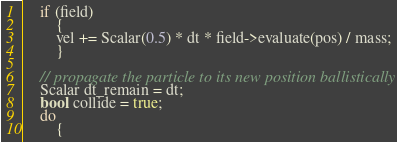Convert code to text. <code><loc_0><loc_0><loc_500><loc_500><_Cuda_>    if (field)
        {
        vel += Scalar(0.5) * dt * field->evaluate(pos) / mass;
        }

    // propagate the particle to its new position ballistically
    Scalar dt_remain = dt;
    bool collide = true;
    do
        {</code> 